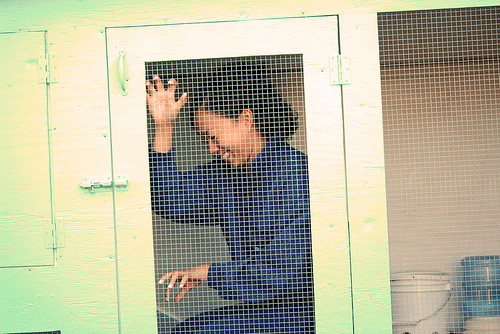<image>
Can you confirm if the woman is next to the door? Yes. The woman is positioned adjacent to the door, located nearby in the same general area. Where is the person in relation to the cabinet? Is it next to the cabinet? No. The person is not positioned next to the cabinet. They are located in different areas of the scene. Is there a door behind the person? No. The door is not behind the person. From this viewpoint, the door appears to be positioned elsewhere in the scene. 